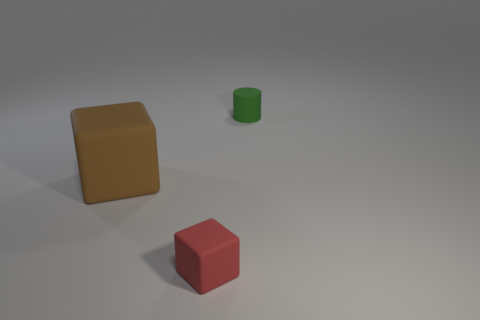Are there fewer tiny cylinders that are in front of the brown object than things behind the small cube?
Your answer should be very brief. Yes. What number of other things are the same size as the brown block?
Provide a succinct answer. 0. Are the brown thing and the tiny thing in front of the tiny cylinder made of the same material?
Your answer should be very brief. Yes. How many things are things that are to the left of the red thing or small objects that are right of the small cube?
Ensure brevity in your answer.  2. What color is the cylinder?
Ensure brevity in your answer.  Green. Are there fewer big blocks that are behind the large brown matte thing than brown matte blocks?
Your answer should be compact. Yes. Are there any other things that have the same shape as the small green thing?
Provide a short and direct response. No. Are there any large brown things?
Your answer should be compact. Yes. Are there fewer tiny green cylinders than tiny purple metal balls?
Your answer should be very brief. No. How many yellow blocks are made of the same material as the small cylinder?
Ensure brevity in your answer.  0. 